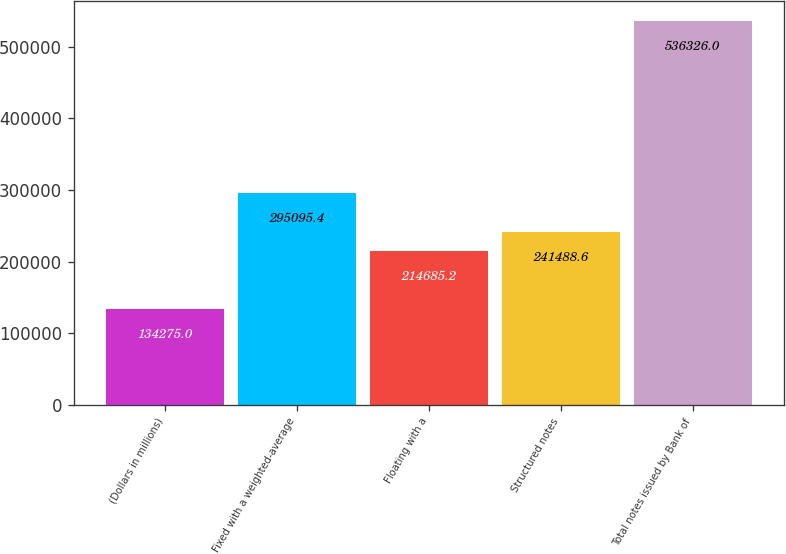<chart> <loc_0><loc_0><loc_500><loc_500><bar_chart><fcel>(Dollars in millions)<fcel>Fixed with a weighted-average<fcel>Floating with a<fcel>Structured notes<fcel>Total notes issued by Bank of<nl><fcel>134275<fcel>295095<fcel>214685<fcel>241489<fcel>536326<nl></chart> 